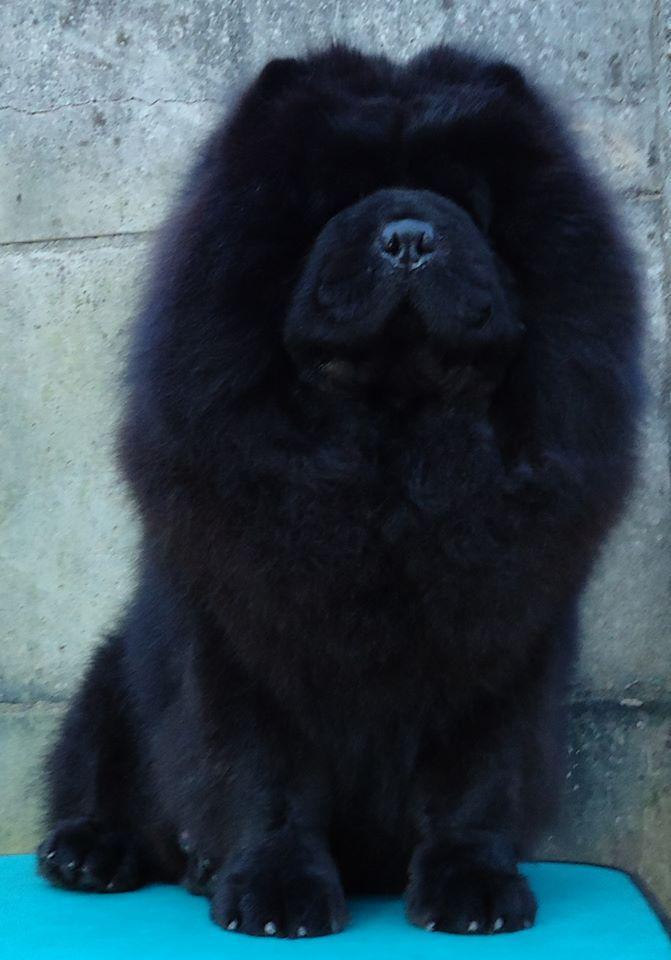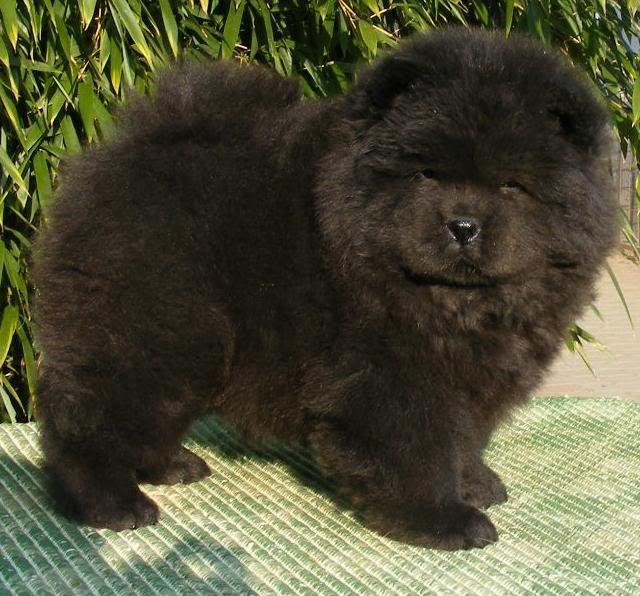The first image is the image on the left, the second image is the image on the right. Analyze the images presented: Is the assertion "An image shows rectangular wire 'mesh' behind one black chow dog." valid? Answer yes or no. No. The first image is the image on the left, the second image is the image on the right. Examine the images to the left and right. Is the description "There are only two dogs and no humans." accurate? Answer yes or no. Yes. 